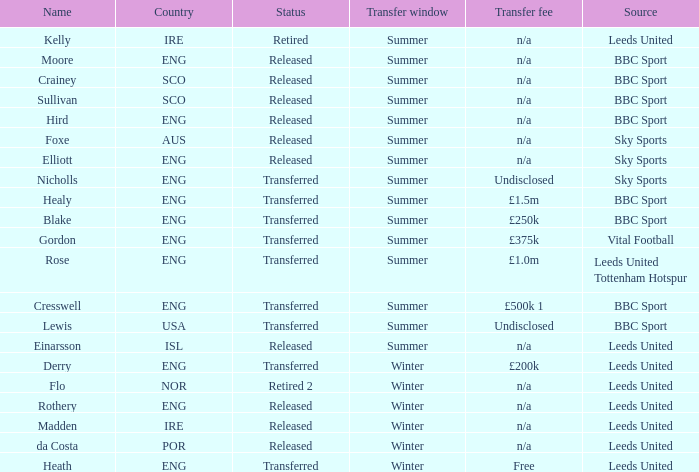What is the current status of the person named Nicholls? Transferred. 